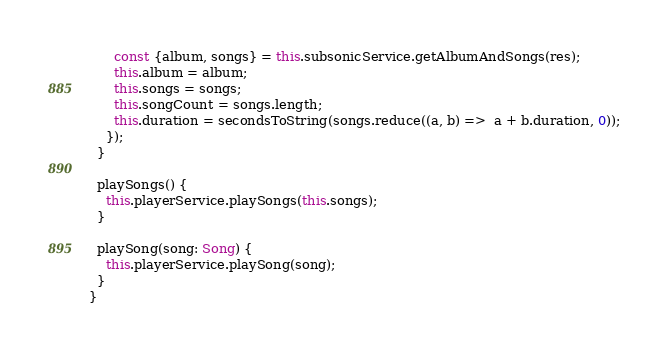Convert code to text. <code><loc_0><loc_0><loc_500><loc_500><_TypeScript_>      const {album, songs} = this.subsonicService.getAlbumAndSongs(res);
      this.album = album;
      this.songs = songs;
      this.songCount = songs.length;
      this.duration = secondsToString(songs.reduce((a, b) =>  a + b.duration, 0));
    });
  }

  playSongs() {
    this.playerService.playSongs(this.songs);
  }

  playSong(song: Song) {
    this.playerService.playSong(song);
  }
}
</code> 